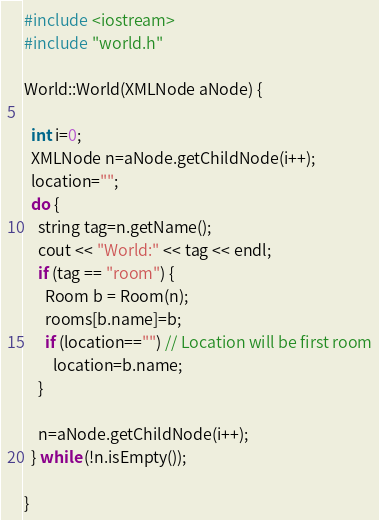Convert code to text. <code><loc_0><loc_0><loc_500><loc_500><_C++_>#include <iostream>
#include "world.h"

World::World(XMLNode aNode) {

  int i=0;
  XMLNode n=aNode.getChildNode(i++);
  location="";
  do {
    string tag=n.getName();
    cout << "World:" << tag << endl;
    if (tag == "room") {
      Room b = Room(n);
      rooms[b.name]=b;
      if (location=="") // Location will be first room
        location=b.name;
    }

    n=aNode.getChildNode(i++);
  } while (!n.isEmpty());

}
</code> 